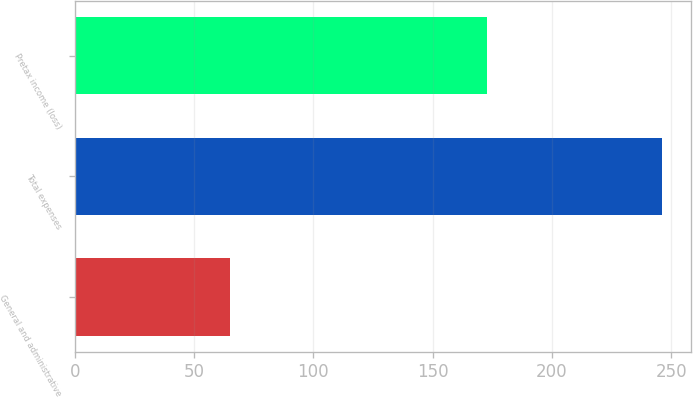Convert chart to OTSL. <chart><loc_0><loc_0><loc_500><loc_500><bar_chart><fcel>General and administrative<fcel>Total expenses<fcel>Pretax income (loss)<nl><fcel>65<fcel>246<fcel>173<nl></chart> 